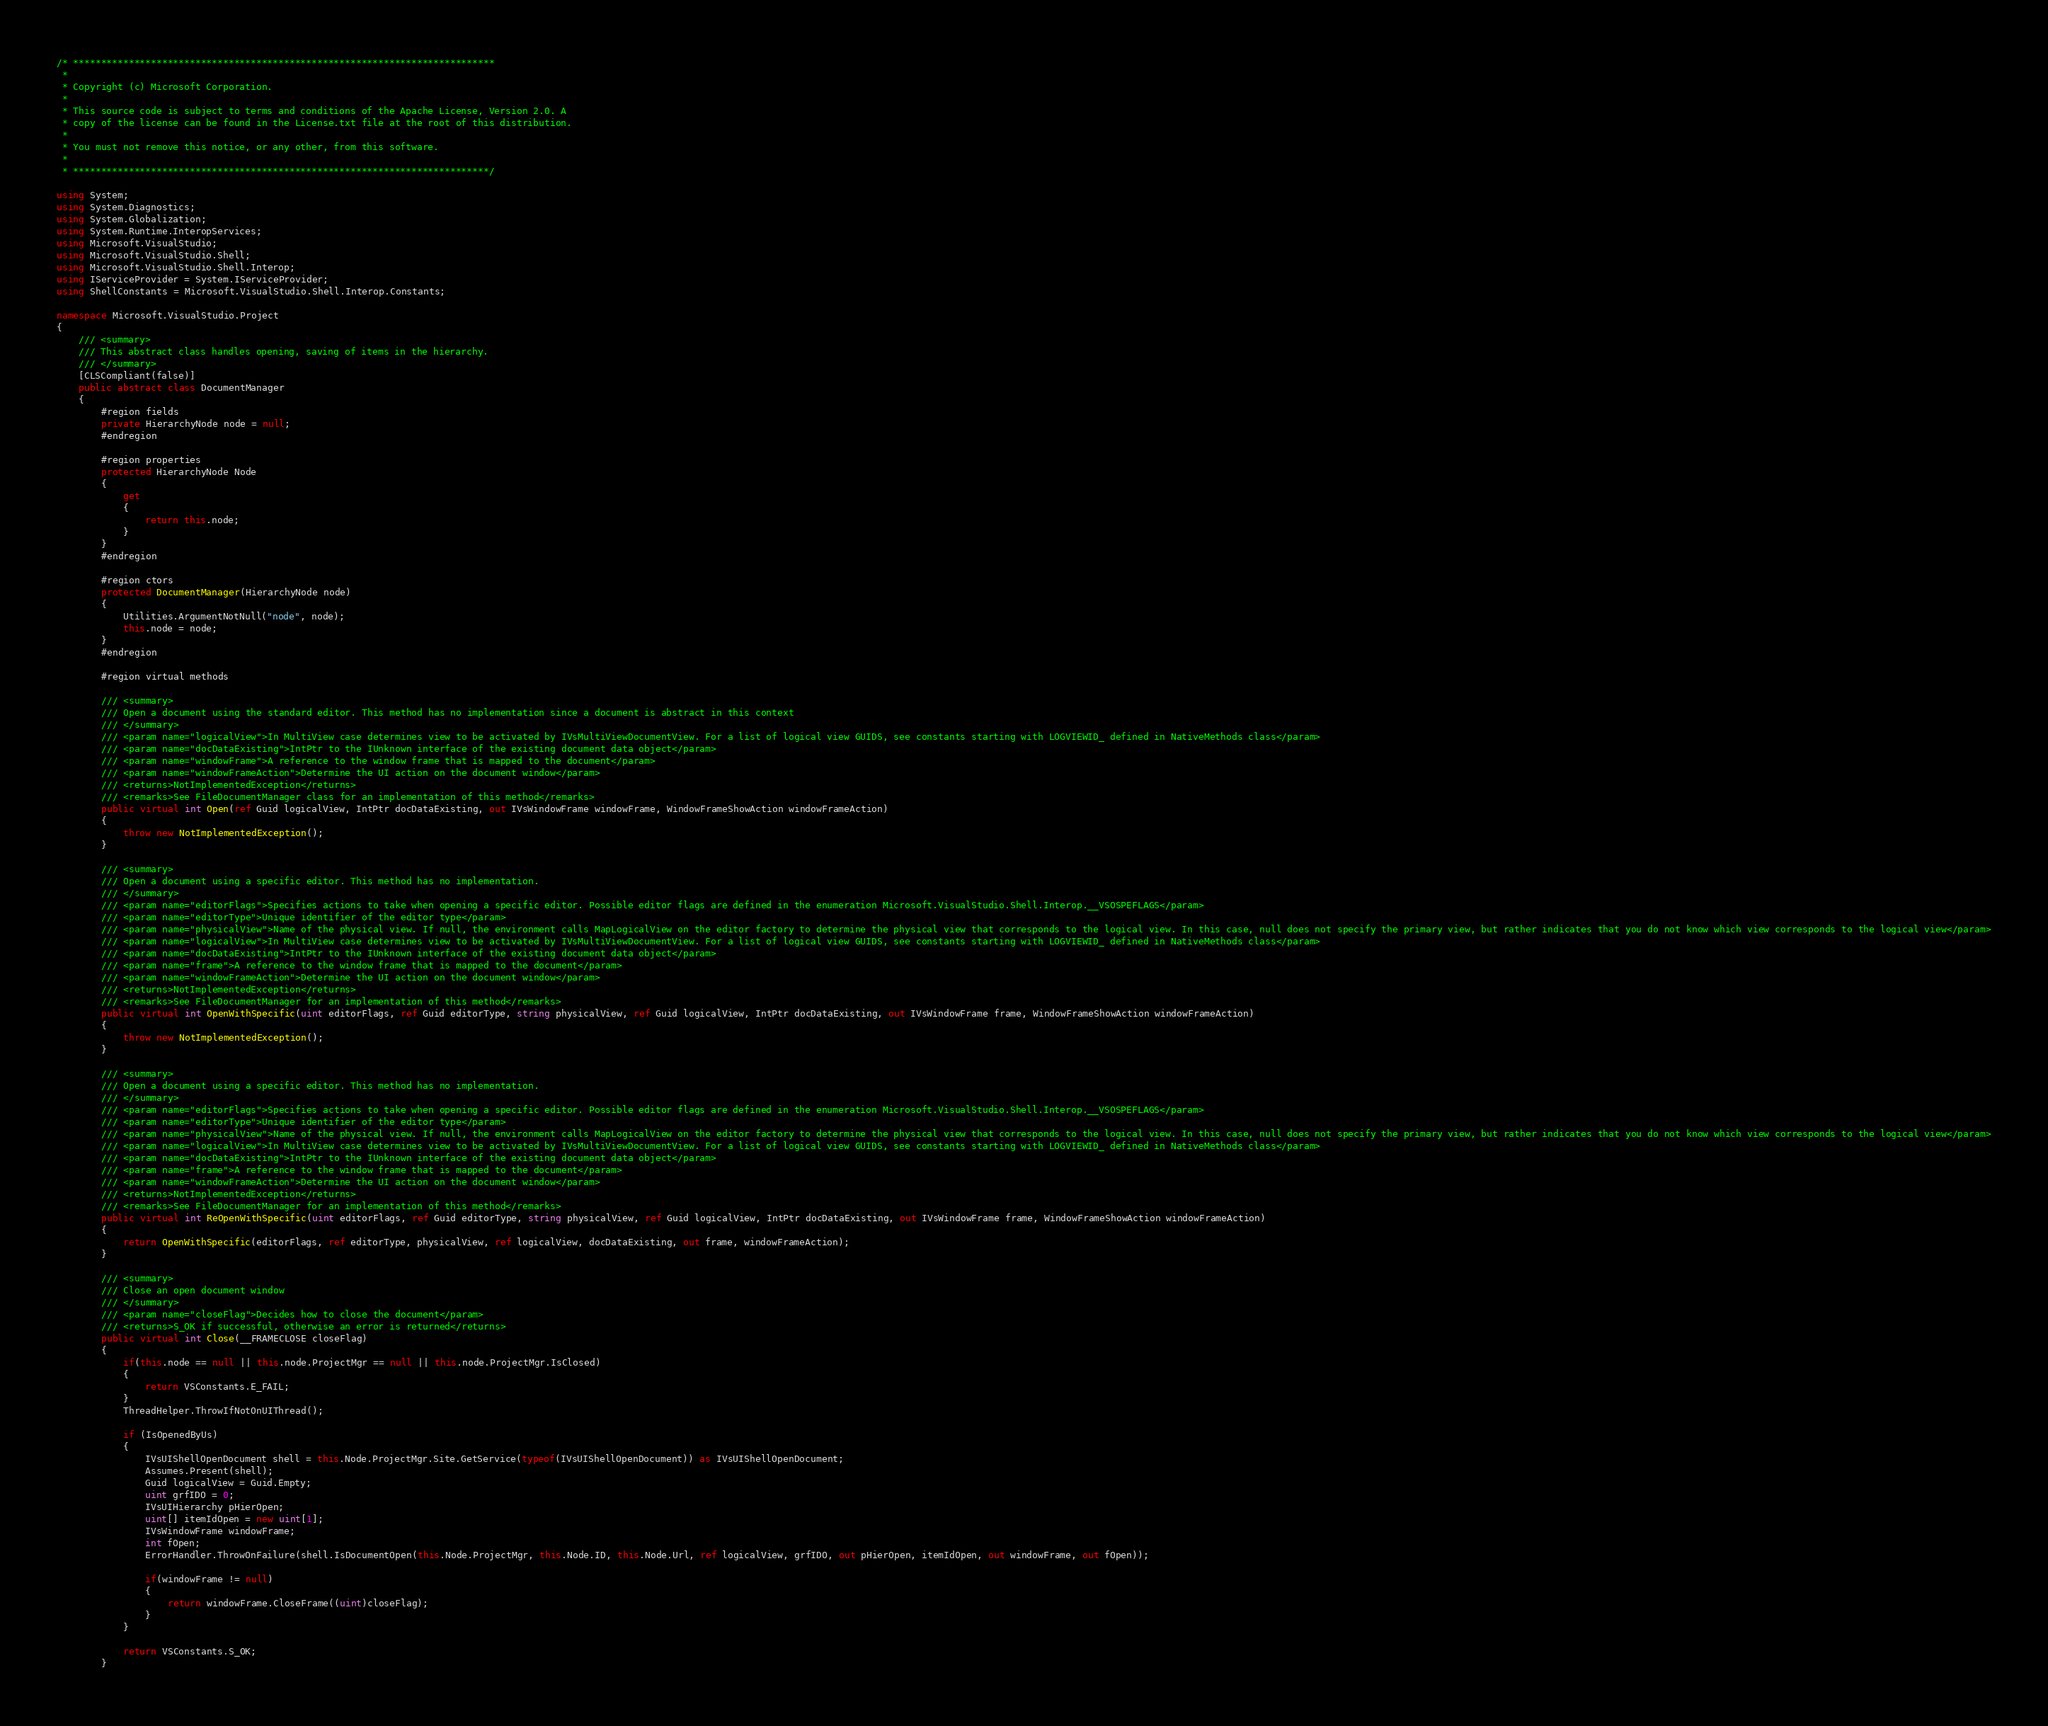Convert code to text. <code><loc_0><loc_0><loc_500><loc_500><_C#_>/* ****************************************************************************
 *
 * Copyright (c) Microsoft Corporation.
 *
 * This source code is subject to terms and conditions of the Apache License, Version 2.0. A
 * copy of the license can be found in the License.txt file at the root of this distribution.
 *
 * You must not remove this notice, or any other, from this software.
 *
 * ***************************************************************************/

using System;
using System.Diagnostics;
using System.Globalization;
using System.Runtime.InteropServices;
using Microsoft.VisualStudio;
using Microsoft.VisualStudio.Shell;
using Microsoft.VisualStudio.Shell.Interop;
using IServiceProvider = System.IServiceProvider;
using ShellConstants = Microsoft.VisualStudio.Shell.Interop.Constants;

namespace Microsoft.VisualStudio.Project
{
    /// <summary>
    /// This abstract class handles opening, saving of items in the hierarchy.
    /// </summary>
    [CLSCompliant(false)]
    public abstract class DocumentManager
    {
        #region fields
        private HierarchyNode node = null;
        #endregion

        #region properties
        protected HierarchyNode Node
        {
            get
            {
                return this.node;
            }
        }
        #endregion

        #region ctors
        protected DocumentManager(HierarchyNode node)
        {
            Utilities.ArgumentNotNull("node", node);
            this.node = node;
        }
        #endregion

        #region virtual methods

        /// <summary>
        /// Open a document using the standard editor. This method has no implementation since a document is abstract in this context
        /// </summary>
        /// <param name="logicalView">In MultiView case determines view to be activated by IVsMultiViewDocumentView. For a list of logical view GUIDS, see constants starting with LOGVIEWID_ defined in NativeMethods class</param>
        /// <param name="docDataExisting">IntPtr to the IUnknown interface of the existing document data object</param>
        /// <param name="windowFrame">A reference to the window frame that is mapped to the document</param>
        /// <param name="windowFrameAction">Determine the UI action on the document window</param>
        /// <returns>NotImplementedException</returns>
        /// <remarks>See FileDocumentManager class for an implementation of this method</remarks>
        public virtual int Open(ref Guid logicalView, IntPtr docDataExisting, out IVsWindowFrame windowFrame, WindowFrameShowAction windowFrameAction)
        {
            throw new NotImplementedException();
        }

        /// <summary>
        /// Open a document using a specific editor. This method has no implementation.
        /// </summary>
        /// <param name="editorFlags">Specifies actions to take when opening a specific editor. Possible editor flags are defined in the enumeration Microsoft.VisualStudio.Shell.Interop.__VSOSPEFLAGS</param>
        /// <param name="editorType">Unique identifier of the editor type</param>
        /// <param name="physicalView">Name of the physical view. If null, the environment calls MapLogicalView on the editor factory to determine the physical view that corresponds to the logical view. In this case, null does not specify the primary view, but rather indicates that you do not know which view corresponds to the logical view</param>
        /// <param name="logicalView">In MultiView case determines view to be activated by IVsMultiViewDocumentView. For a list of logical view GUIDS, see constants starting with LOGVIEWID_ defined in NativeMethods class</param>
        /// <param name="docDataExisting">IntPtr to the IUnknown interface of the existing document data object</param>
        /// <param name="frame">A reference to the window frame that is mapped to the document</param>
        /// <param name="windowFrameAction">Determine the UI action on the document window</param>
        /// <returns>NotImplementedException</returns>
        /// <remarks>See FileDocumentManager for an implementation of this method</remarks>
        public virtual int OpenWithSpecific(uint editorFlags, ref Guid editorType, string physicalView, ref Guid logicalView, IntPtr docDataExisting, out IVsWindowFrame frame, WindowFrameShowAction windowFrameAction)
        {
            throw new NotImplementedException();
        }

        /// <summary>
        /// Open a document using a specific editor. This method has no implementation.
        /// </summary>
        /// <param name="editorFlags">Specifies actions to take when opening a specific editor. Possible editor flags are defined in the enumeration Microsoft.VisualStudio.Shell.Interop.__VSOSPEFLAGS</param>
        /// <param name="editorType">Unique identifier of the editor type</param>
        /// <param name="physicalView">Name of the physical view. If null, the environment calls MapLogicalView on the editor factory to determine the physical view that corresponds to the logical view. In this case, null does not specify the primary view, but rather indicates that you do not know which view corresponds to the logical view</param>
        /// <param name="logicalView">In MultiView case determines view to be activated by IVsMultiViewDocumentView. For a list of logical view GUIDS, see constants starting with LOGVIEWID_ defined in NativeMethods class</param>
        /// <param name="docDataExisting">IntPtr to the IUnknown interface of the existing document data object</param>
        /// <param name="frame">A reference to the window frame that is mapped to the document</param>
        /// <param name="windowFrameAction">Determine the UI action on the document window</param>
        /// <returns>NotImplementedException</returns>
        /// <remarks>See FileDocumentManager for an implementation of this method</remarks>
        public virtual int ReOpenWithSpecific(uint editorFlags, ref Guid editorType, string physicalView, ref Guid logicalView, IntPtr docDataExisting, out IVsWindowFrame frame, WindowFrameShowAction windowFrameAction)
		{
            return OpenWithSpecific(editorFlags, ref editorType, physicalView, ref logicalView, docDataExisting, out frame, windowFrameAction);
        }

        /// <summary>
        /// Close an open document window
        /// </summary>
        /// <param name="closeFlag">Decides how to close the document</param>
        /// <returns>S_OK if successful, otherwise an error is returned</returns>
        public virtual int Close(__FRAMECLOSE closeFlag)
        {
            if(this.node == null || this.node.ProjectMgr == null || this.node.ProjectMgr.IsClosed)
            {
                return VSConstants.E_FAIL;
            }
            ThreadHelper.ThrowIfNotOnUIThread();

            if (IsOpenedByUs)
            {
                IVsUIShellOpenDocument shell = this.Node.ProjectMgr.Site.GetService(typeof(IVsUIShellOpenDocument)) as IVsUIShellOpenDocument;
                Assumes.Present(shell);
                Guid logicalView = Guid.Empty;
                uint grfIDO = 0;
                IVsUIHierarchy pHierOpen;
                uint[] itemIdOpen = new uint[1];
                IVsWindowFrame windowFrame;
                int fOpen;
                ErrorHandler.ThrowOnFailure(shell.IsDocumentOpen(this.Node.ProjectMgr, this.Node.ID, this.Node.Url, ref logicalView, grfIDO, out pHierOpen, itemIdOpen, out windowFrame, out fOpen));

                if(windowFrame != null)
                {
                    return windowFrame.CloseFrame((uint)closeFlag);
                }
            }

            return VSConstants.S_OK;
        }
</code> 